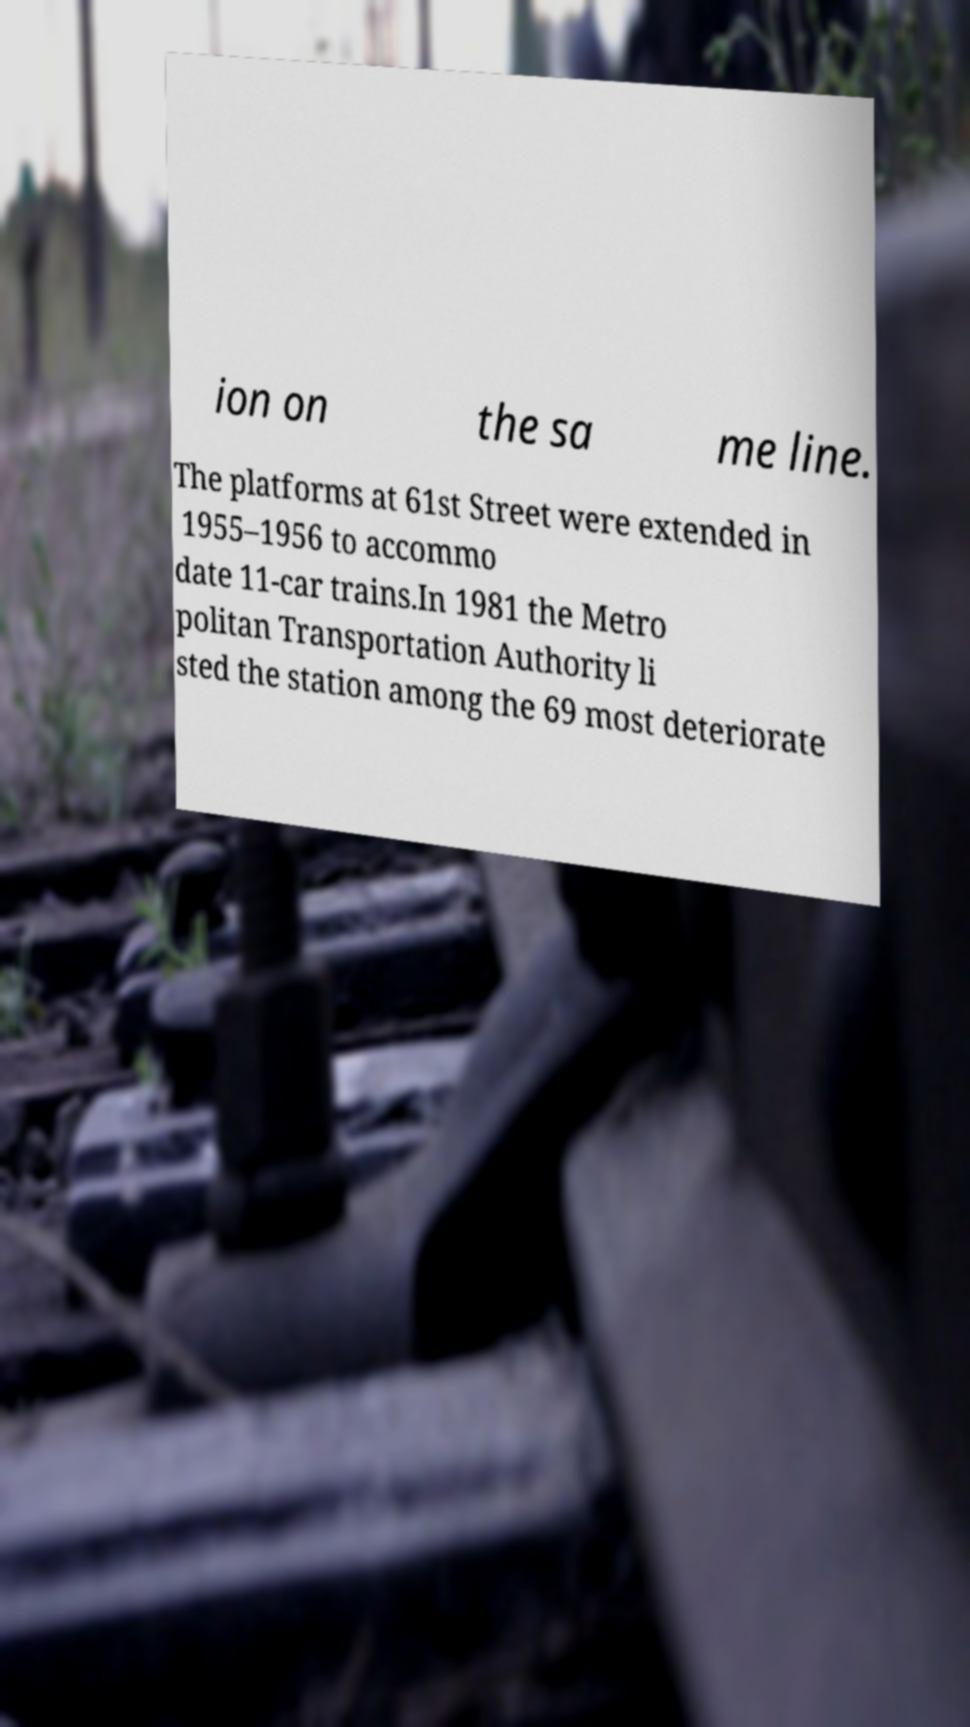Please read and relay the text visible in this image. What does it say? ion on the sa me line. The platforms at 61st Street were extended in 1955–1956 to accommo date 11-car trains.In 1981 the Metro politan Transportation Authority li sted the station among the 69 most deteriorate 